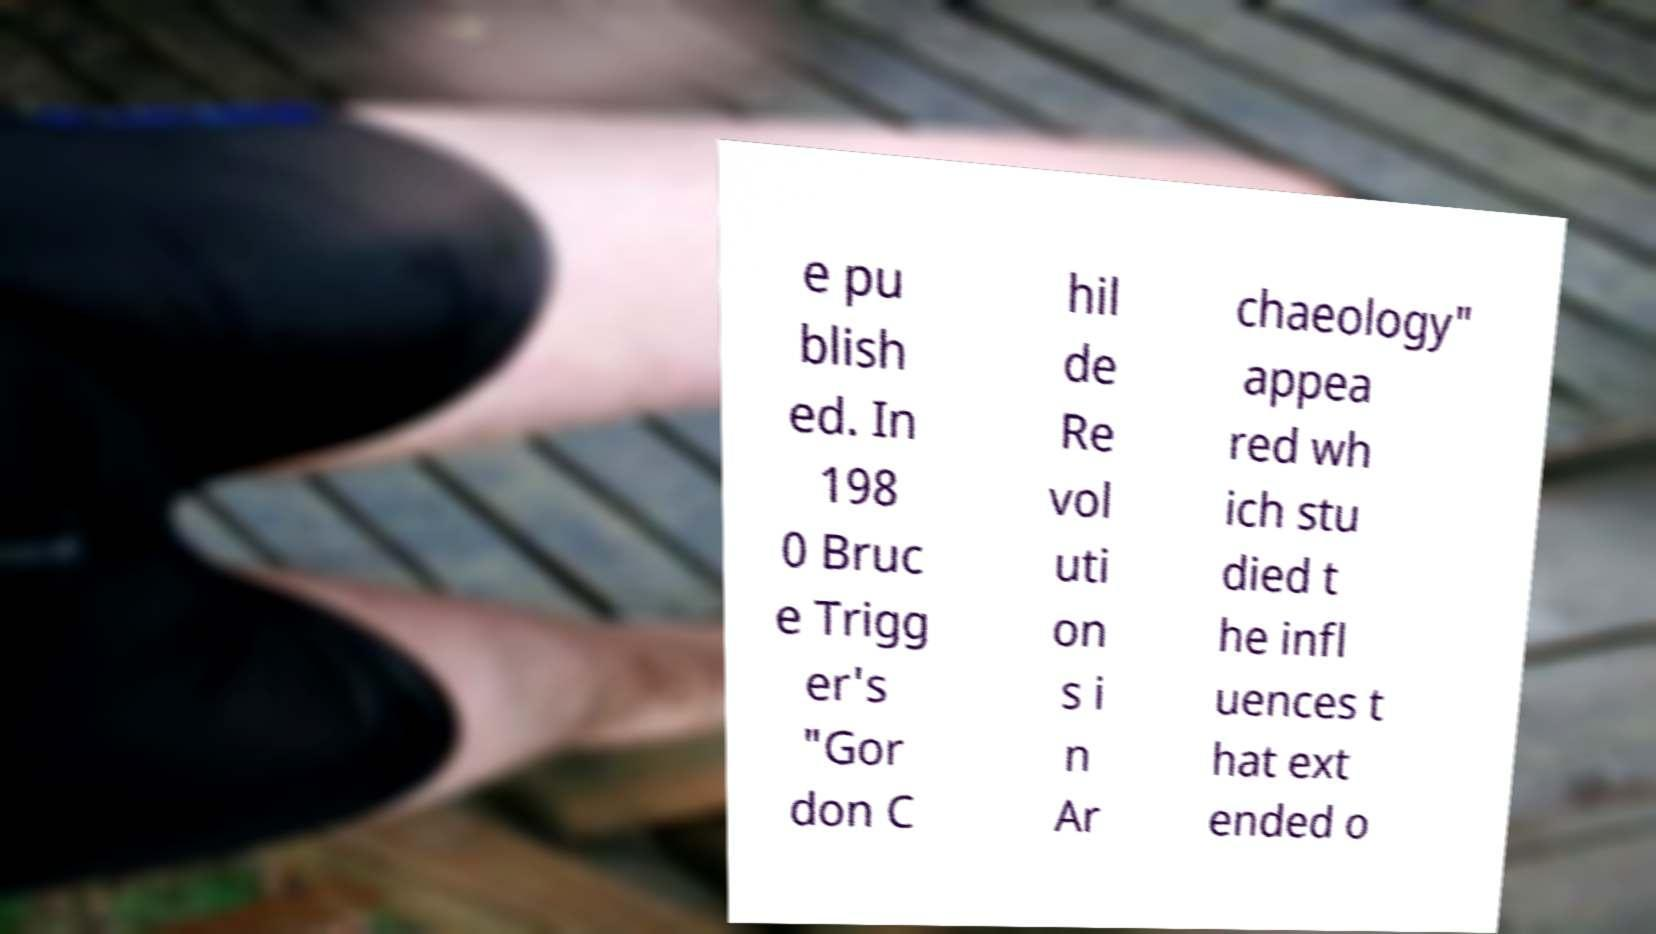Please read and relay the text visible in this image. What does it say? e pu blish ed. In 198 0 Bruc e Trigg er's "Gor don C hil de Re vol uti on s i n Ar chaeology" appea red wh ich stu died t he infl uences t hat ext ended o 